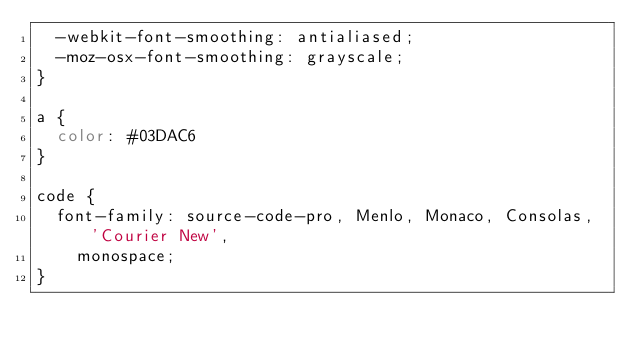Convert code to text. <code><loc_0><loc_0><loc_500><loc_500><_CSS_>  -webkit-font-smoothing: antialiased;
  -moz-osx-font-smoothing: grayscale;
}

a {
  color: #03DAC6
}

code {
  font-family: source-code-pro, Menlo, Monaco, Consolas, 'Courier New',
    monospace;
}
</code> 